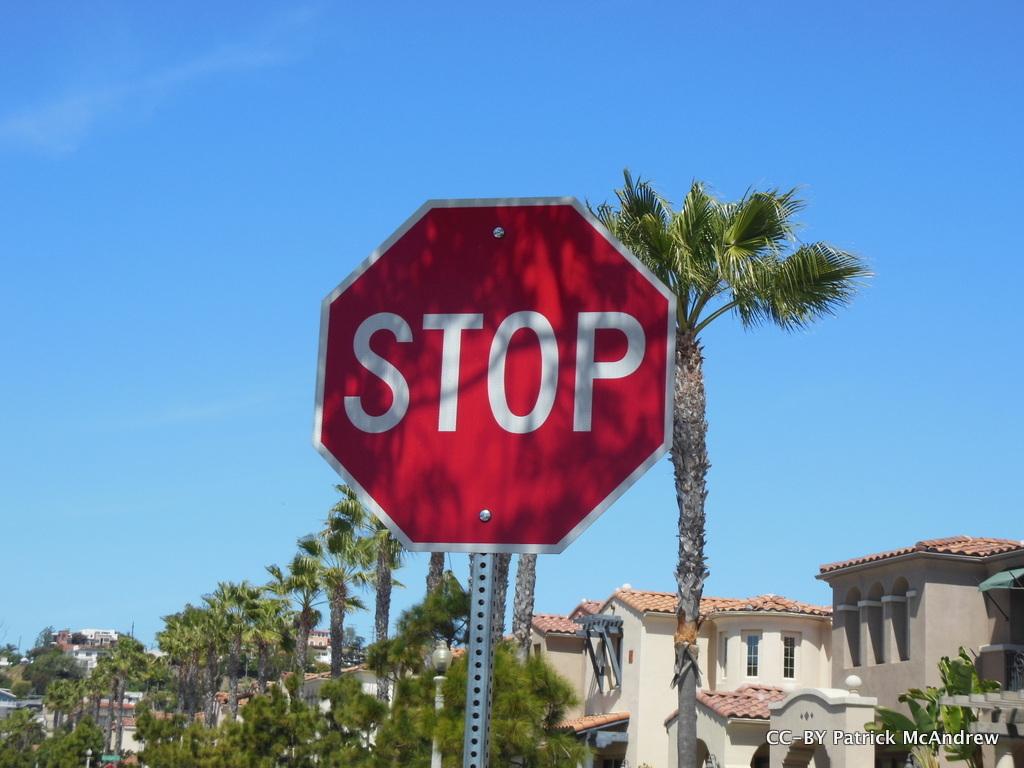What does the sign instructed you to do?
Your response must be concise. Stop. 